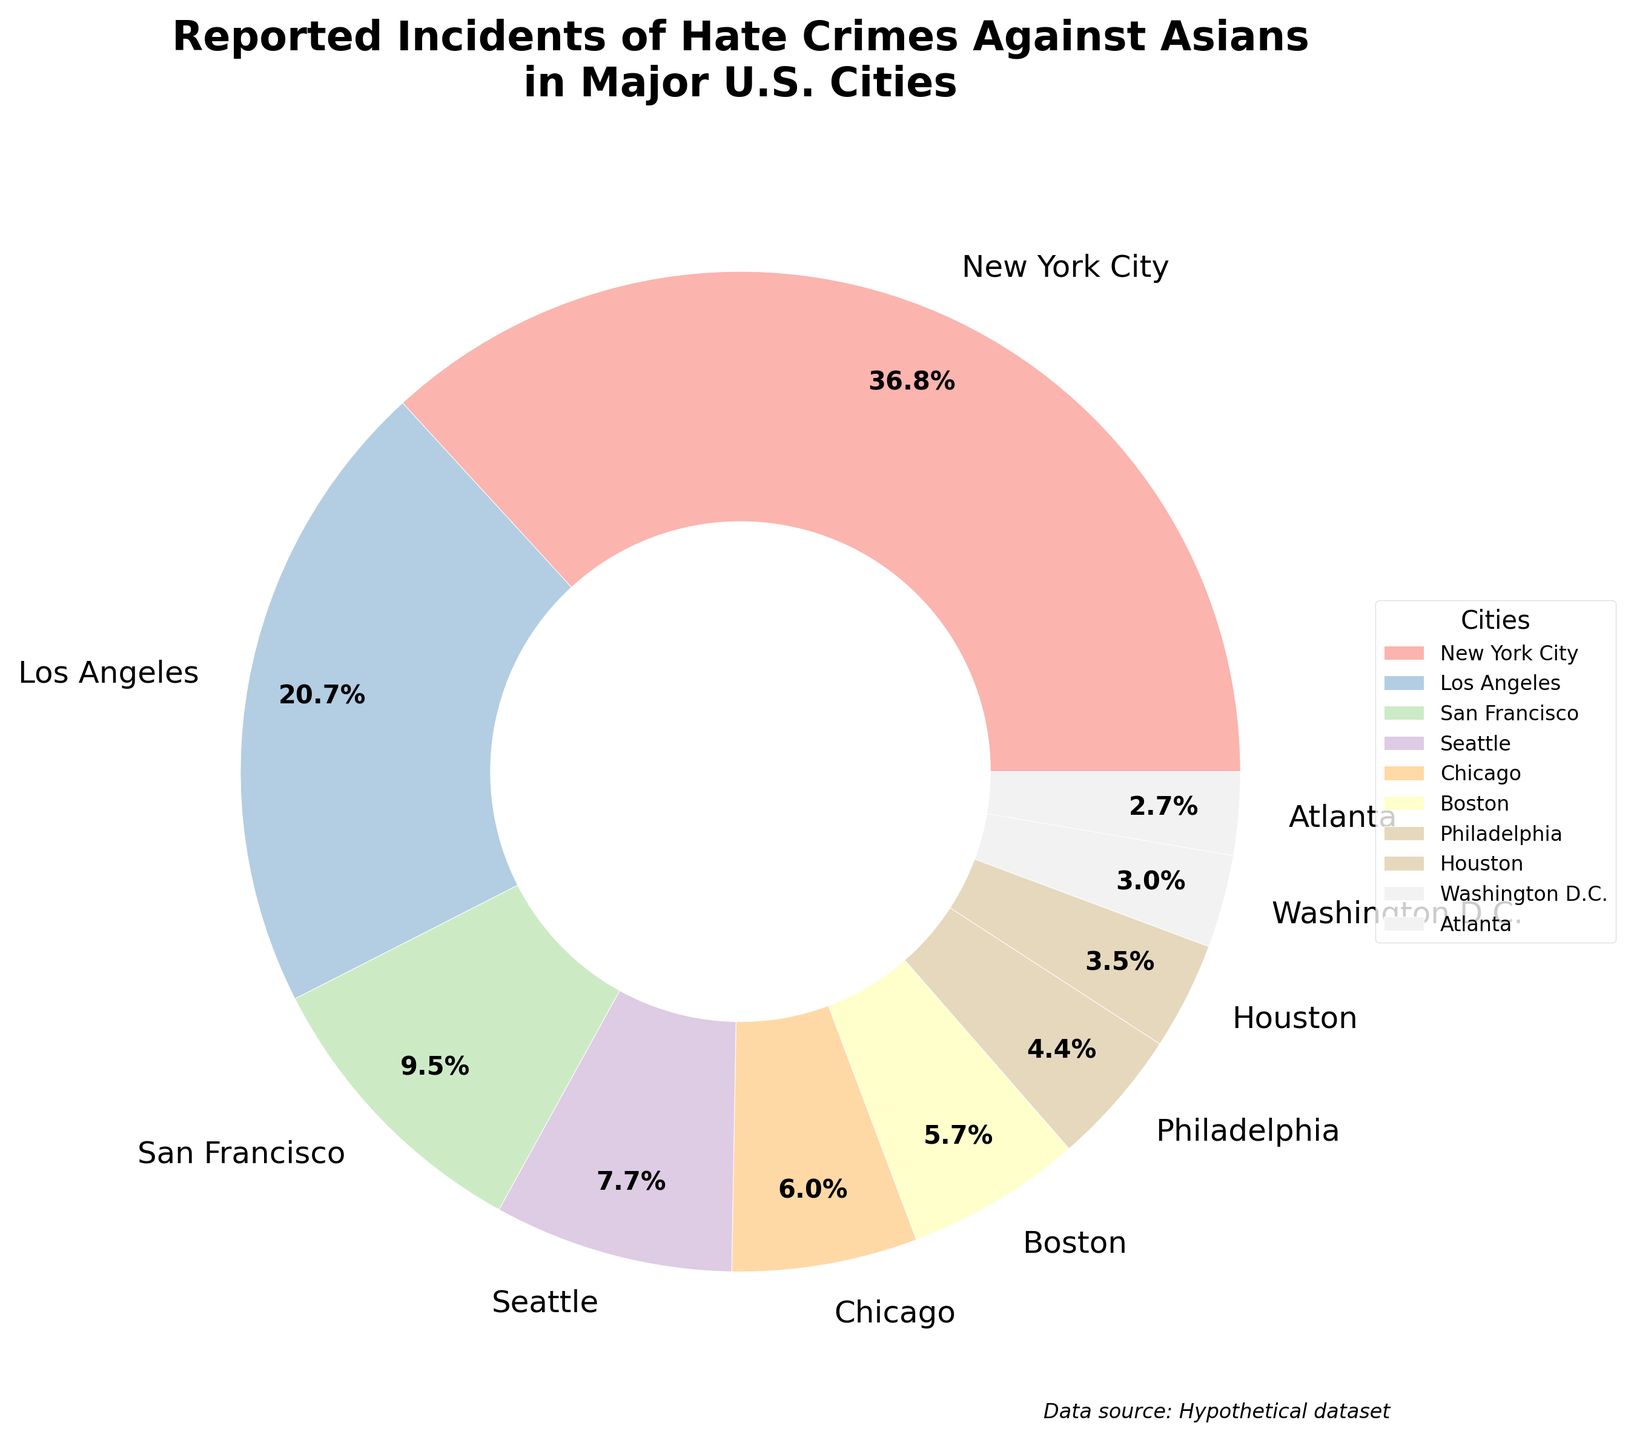What's the city with the highest reported hate crimes against Asians? The pie chart shows that New York City has the largest wedge, indicating the highest number of reported hate crimes.
Answer: New York City Which city has fewer reported hate crimes against Asians, Atlanta or Houston? From the pie chart, the wedge for Atlanta is smaller than the wedge for Houston.
Answer: Atlanta What is the difference in the number of reported hate crimes against Asians between Los Angeles and San Francisco? According to the data, Los Angeles has 131 reported cases, and San Francisco has 60. The difference is 131 - 60.
Answer: 71 How many cities reported fewer than 40 hate crimes against Asians? From the pie chart, Chicago, Boston, Philadelphia, Houston, Washington D.C., and Atlanta all reported fewer than 40 cases. So, there are 6 cities in total.
Answer: 6 What is the total number of reported hate crimes against Asians in Philadelphia, Houston, and Atlanta? Adding the reported cases: Philadelphia has 28, Houston has 22, and Atlanta has 17. The total is 28 + 22 + 17.
Answer: 67 Is the number of reported hate crimes against Asians in Chicago greater than the sum of those in Washington D.C. and Atlanta? Chicago reported 38 cases. Washington D.C. has 19 cases, and Atlanta has 17 cases. Adding those together: 19 + 17 = 36. Since 38 > 36, the answer is yes.
Answer: Yes Which slice in the pie chart is visually the smallest, and what might be a reason for this? The smallest slice in the pie chart represents Atlanta, likely because it has the fewest reported hate crimes against Asians.
Answer: Atlanta What percentage of the total reported hate crimes are from Boston? From the pie chart, Boston is represented in a way that indicates 36 reported cases. To find the percentage: (36 / (233+131+60+49+38+36+28+22+19+17)) * 100%. Sum of all reports is 633. So, (36 / 633) * 100.
Answer: 5.7% How does Seattle compare to San Francisco in terms of reported hate crimes? The pie chart shows that Seattle’s wedge is smaller than San Francisco’s, indicating fewer reported hate crimes.
Answer: Fewer 